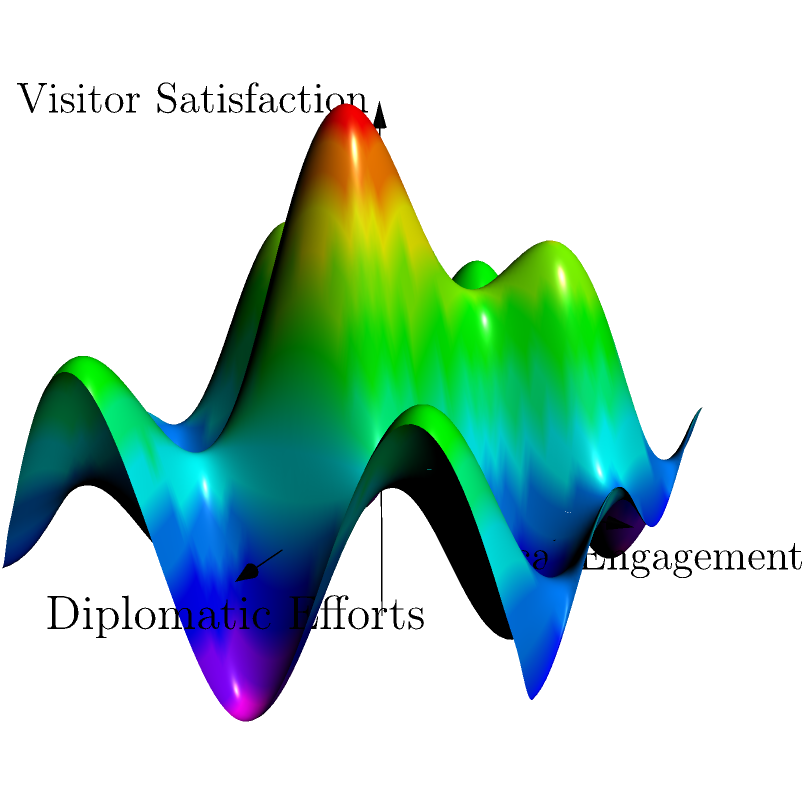The surface shown represents the relationship between diplomatic efforts (x-axis), local engagement (y-axis), and international visitor satisfaction (z-axis). The function describing this surface is:

$$z = f(x,y) = 0.5e^{-0.1(x^2+y^2)} + 0.3\sin(x)\cos(y)$$

Where should the diplomat focus their efforts to maximize visitor satisfaction? Find the local maximum of the function and interpret its meaning in the context of diplomatic work. To find the local maximum, we need to follow these steps:

1) Calculate the partial derivatives of $f(x,y)$ with respect to $x$ and $y$:

   $$\frac{\partial f}{\partial x} = -0.1x e^{-0.1(x^2+y^2)} + 0.3\cos(x)\cos(y)$$
   $$\frac{\partial f}{\partial y} = -0.1y e^{-0.1(x^2+y^2)} - 0.3\sin(x)\sin(y)$$

2) Set both partial derivatives to zero and solve the system of equations:

   $$-0.1x e^{-0.1(x^2+y^2)} + 0.3\cos(x)\cos(y) = 0$$
   $$-0.1y e^{-0.1(x^2+y^2)} - 0.3\sin(x)\sin(y) = 0$$

3) Due to the complexity of these equations, we can't solve them analytically. However, we can observe that $(x,y) = (0,0)$ is a solution, as it makes both equations true.

4) To confirm this is a local maximum, we need to check the second partial derivatives:

   $$\frac{\partial^2 f}{\partial x^2} = (0.01x^2 - 0.1) e^{-0.1(x^2+y^2)} - 0.3\sin(x)\cos(y)$$
   $$\frac{\partial^2 f}{\partial y^2} = (0.01y^2 - 0.1) e^{-0.1(x^2+y^2)} - 0.3\sin(y)\cos(x)$$
   $$\frac{\partial^2 f}{\partial x\partial y} = 0.01xy e^{-0.1(x^2+y^2)} + 0.3\sin(x)\sin(y)$$

5) At $(0,0)$, these become:

   $$\frac{\partial^2 f}{\partial x^2}(0,0) = -0.1$$
   $$\frac{\partial^2 f}{\partial y^2}(0,0) = -0.1$$
   $$\frac{\partial^2 f}{\partial x\partial y}(0,0) = 0$$

6) The Hessian matrix at $(0,0)$ is:

   $$H = \begin{bmatrix} -0.1 & 0 \\ 0 & -0.1 \end{bmatrix}$$

   Since both eigenvalues are negative, $(0,0)$ is indeed a local maximum.

7) The maximum value of $f(x,y)$ at $(0,0)$ is:

   $$f(0,0) = 0.5e^{-0.1(0^2+0^2)} + 0.3\sin(0)\cos(0) = 0.5$$

Interpretation: The diplomat should balance their efforts equally between diplomatic efforts and local engagement (both at 0 on their respective axes). This balanced approach leads to the highest visitor satisfaction of 0.5 on the z-axis.
Answer: Balance diplomatic efforts and local engagement equally (0,0) for maximum visitor satisfaction of 0.5. 